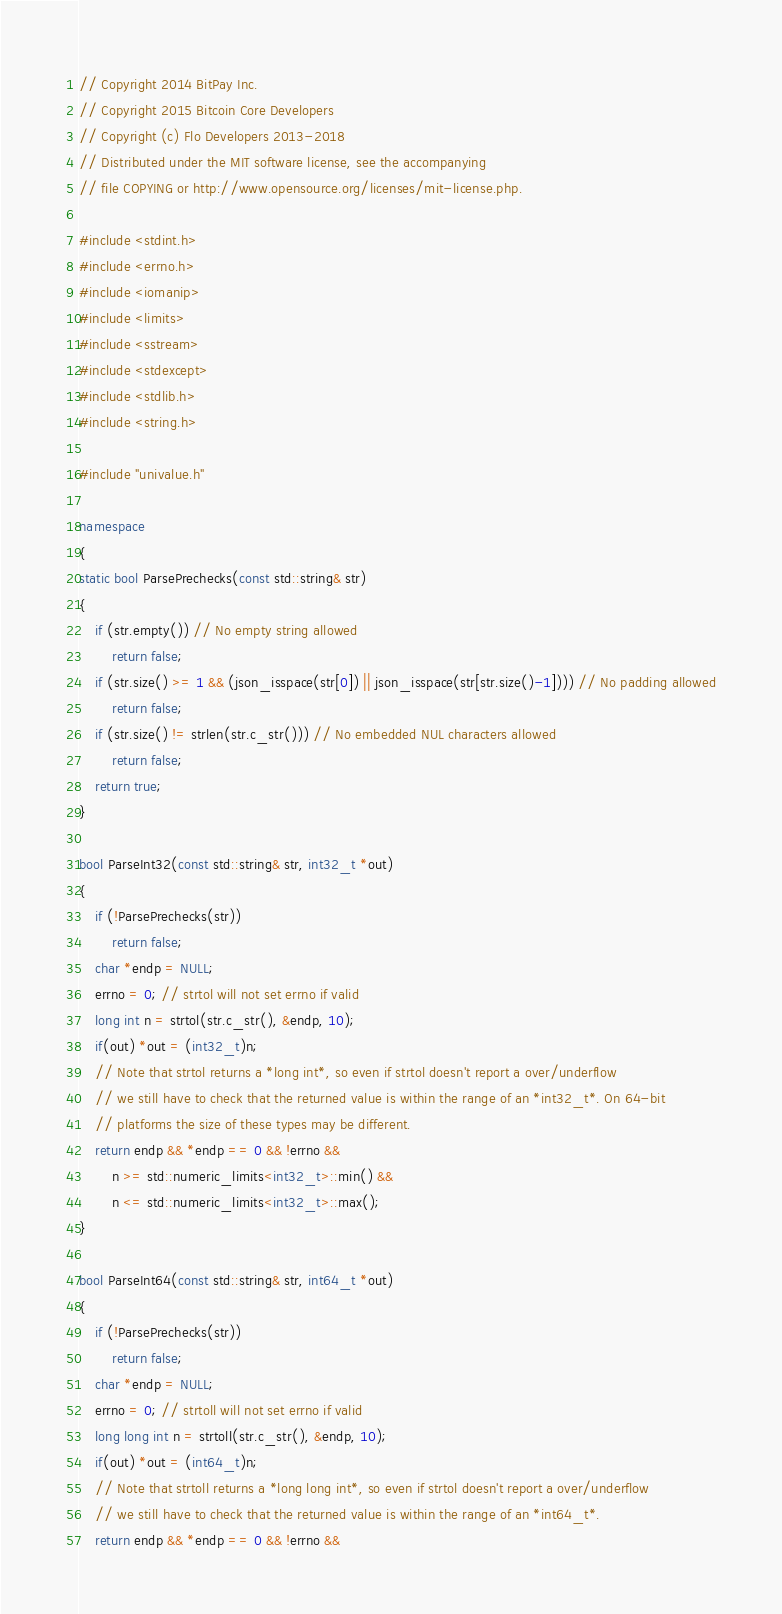Convert code to text. <code><loc_0><loc_0><loc_500><loc_500><_C++_>// Copyright 2014 BitPay Inc.
// Copyright 2015 Bitcoin Core Developers
// Copyright (c) Flo Developers 2013-2018
// Distributed under the MIT software license, see the accompanying
// file COPYING or http://www.opensource.org/licenses/mit-license.php.

#include <stdint.h>
#include <errno.h>
#include <iomanip>
#include <limits>
#include <sstream>
#include <stdexcept>
#include <stdlib.h>
#include <string.h>

#include "univalue.h"

namespace 
{
static bool ParsePrechecks(const std::string& str)
{
    if (str.empty()) // No empty string allowed
        return false;
    if (str.size() >= 1 && (json_isspace(str[0]) || json_isspace(str[str.size()-1]))) // No padding allowed
        return false;
    if (str.size() != strlen(str.c_str())) // No embedded NUL characters allowed
        return false;
    return true;
}

bool ParseInt32(const std::string& str, int32_t *out)
{
    if (!ParsePrechecks(str))
        return false;
    char *endp = NULL;
    errno = 0; // strtol will not set errno if valid
    long int n = strtol(str.c_str(), &endp, 10);
    if(out) *out = (int32_t)n;
    // Note that strtol returns a *long int*, so even if strtol doesn't report a over/underflow
    // we still have to check that the returned value is within the range of an *int32_t*. On 64-bit
    // platforms the size of these types may be different.
    return endp && *endp == 0 && !errno &&
        n >= std::numeric_limits<int32_t>::min() &&
        n <= std::numeric_limits<int32_t>::max();
}

bool ParseInt64(const std::string& str, int64_t *out)
{
    if (!ParsePrechecks(str))
        return false;
    char *endp = NULL;
    errno = 0; // strtoll will not set errno if valid
    long long int n = strtoll(str.c_str(), &endp, 10);
    if(out) *out = (int64_t)n;
    // Note that strtoll returns a *long long int*, so even if strtol doesn't report a over/underflow
    // we still have to check that the returned value is within the range of an *int64_t*.
    return endp && *endp == 0 && !errno &&</code> 